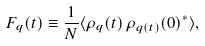Convert formula to latex. <formula><loc_0><loc_0><loc_500><loc_500>F _ { q } ( t ) \equiv \frac { 1 } { N } \langle \rho _ { q } ( t ) \, \rho _ { { q } ( t ) } ( 0 ) ^ { * } \rangle ,</formula> 